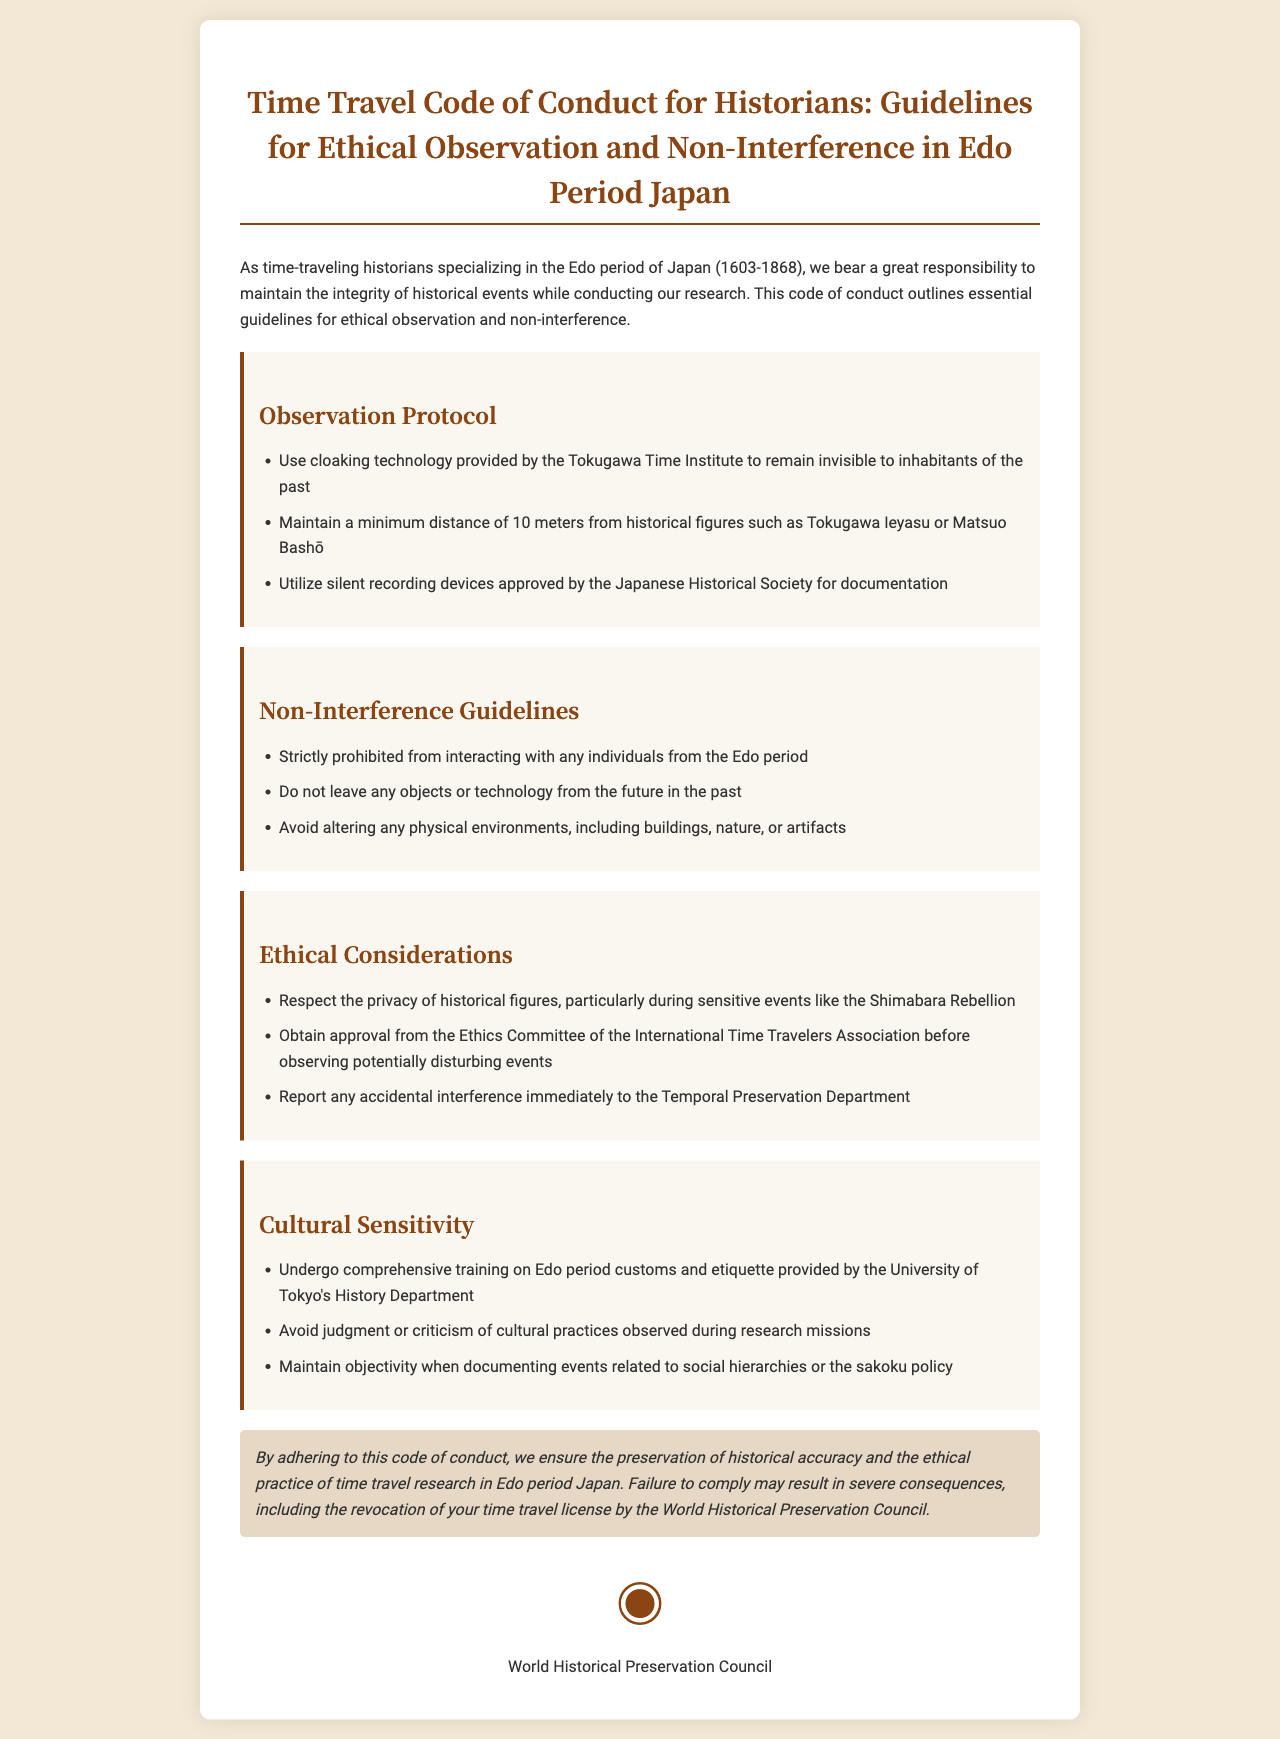What is the title of the document? The title provides the formal name of the document, which is specified in the header section.
Answer: Time Travel Code of Conduct for Historians: Guidelines for Ethical Observation and Non-Interference in Edo Period Japan What organization provides cloaking technology? The document states who provides the cloaking technology essential for the observation protocol.
Answer: Tokugawa Time Institute What is the minimum distance to maintain from historical figures? This is a specific numerical guideline mentioned in the observation protocol regarding interaction proximity.
Answer: 10 meters Who must approve observation of potentially disturbing events? The document indicates which committee's approval is required before observing sensitive historical moments.
Answer: Ethics Committee of the International Time Travelers Association In which period are historians specializing according to the document? The document outlines the historical period that the guidelines focus on for the historians' research.
Answer: Edo period of Japan What is strictly prohibited in terms of interacting with individuals? The document emphasizes a specific action that historians must not engage in with historical figures.
Answer: Interacting with any individuals from the Edo period What type of training is required before research missions? The document specifies the nature of training required for historians to respect cultural practices.
Answer: Comprehensive training on Edo period customs and etiquette What can happen for failure to comply with the code? This section outlines the consequences faced if the guidelines are not followed, specifically relating to their authority.
Answer: Revocation of your time travel license by the World Historical Preservation Council What should be reported immediately after accidental interference? The document directs immediate reporting for a particular situation regarding temporal integrity.
Answer: Temporal Preservation Department 